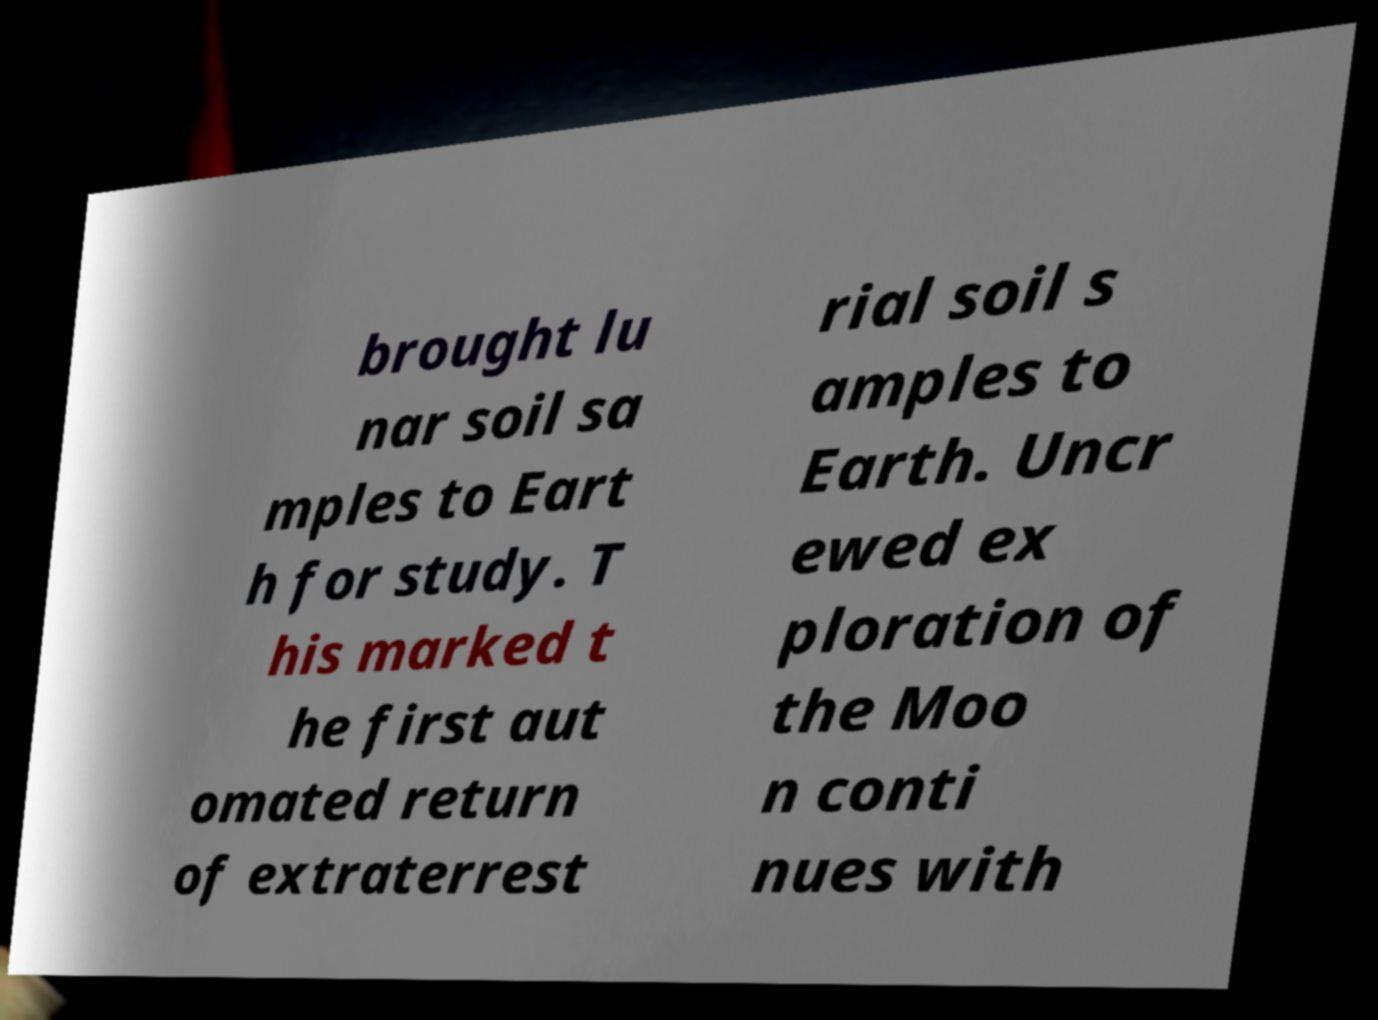Please read and relay the text visible in this image. What does it say? brought lu nar soil sa mples to Eart h for study. T his marked t he first aut omated return of extraterrest rial soil s amples to Earth. Uncr ewed ex ploration of the Moo n conti nues with 